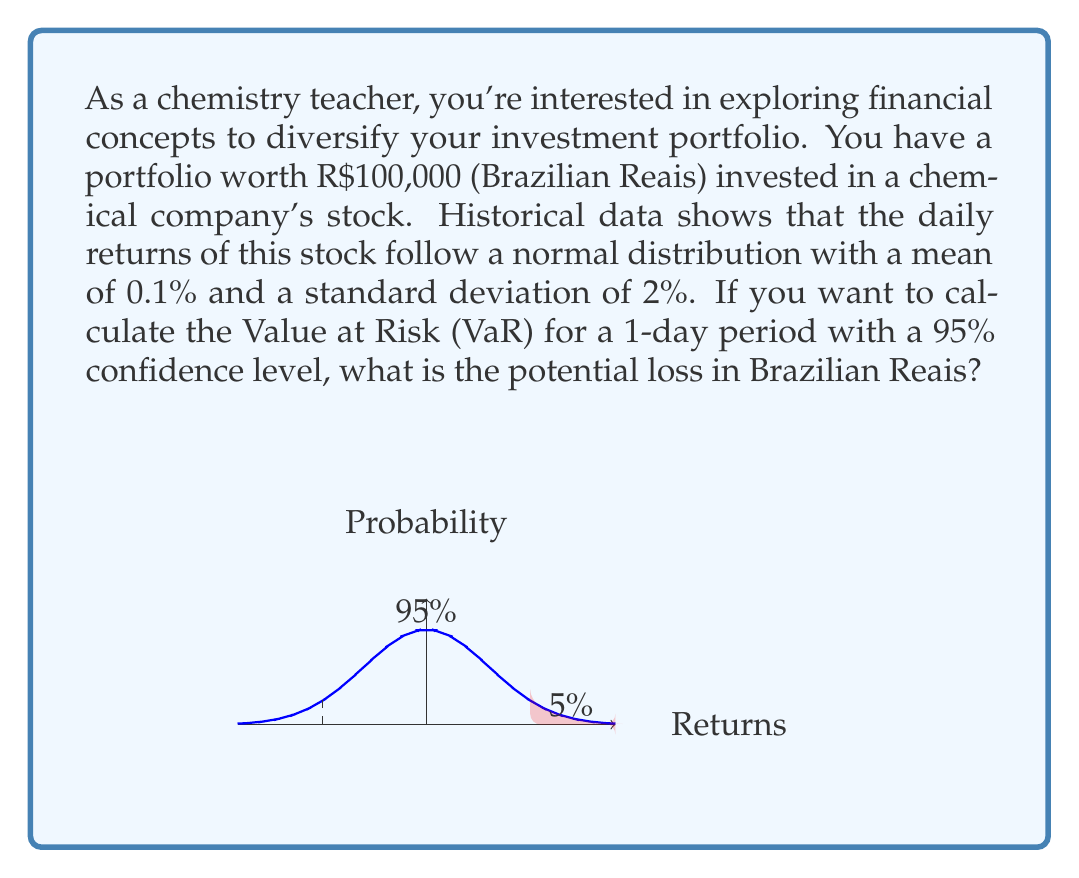Solve this math problem. To calculate the Value at Risk (VaR) for this scenario, we'll follow these steps:

1) The VaR at 95% confidence level corresponds to the 5th percentile of the return distribution.

2) For a normal distribution, the 5th percentile is 1.645 standard deviations below the mean.

3) Calculate the VaR in terms of returns:
   $VaR_{return} = \mu - 1.645 \sigma$
   $VaR_{return} = 0.001 - 1.645 * 0.02 = -0.0319$ or -3.19%

4) Convert the VaR from returns to Brazilian Reais:
   $VaR_{BRL} = Portfolio Value * VaR_{return}$
   $VaR_{BRL} = 100,000 * 0.0319 = 3,190$

Therefore, with 95% confidence, the maximum loss over a 1-day period is R$3,190.
Answer: R$3,190 